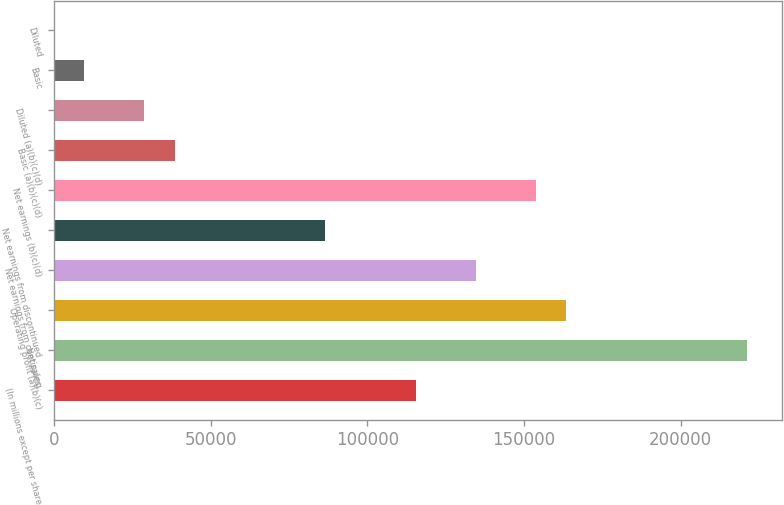Convert chart to OTSL. <chart><loc_0><loc_0><loc_500><loc_500><bar_chart><fcel>(In millions except per share<fcel>Net sales<fcel>Operating profit (a)(b)(c)<fcel>Net earnings from continuing<fcel>Net earnings from discontinued<fcel>Net earnings (b)(c)(d)<fcel>Basic (a)(b)(c)(d)<fcel>Diluted (a)(b)(c)(d)<fcel>Basic<fcel>Diluted<nl><fcel>115389<fcel>221157<fcel>163465<fcel>134619<fcel>86542.7<fcel>153850<fcel>38466.3<fcel>28851<fcel>9620.4<fcel>5.11<nl></chart> 